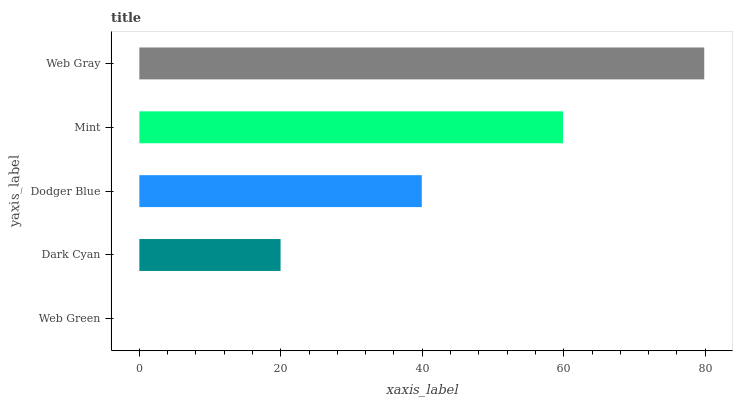Is Web Green the minimum?
Answer yes or no. Yes. Is Web Gray the maximum?
Answer yes or no. Yes. Is Dark Cyan the minimum?
Answer yes or no. No. Is Dark Cyan the maximum?
Answer yes or no. No. Is Dark Cyan greater than Web Green?
Answer yes or no. Yes. Is Web Green less than Dark Cyan?
Answer yes or no. Yes. Is Web Green greater than Dark Cyan?
Answer yes or no. No. Is Dark Cyan less than Web Green?
Answer yes or no. No. Is Dodger Blue the high median?
Answer yes or no. Yes. Is Dodger Blue the low median?
Answer yes or no. Yes. Is Mint the high median?
Answer yes or no. No. Is Web Gray the low median?
Answer yes or no. No. 